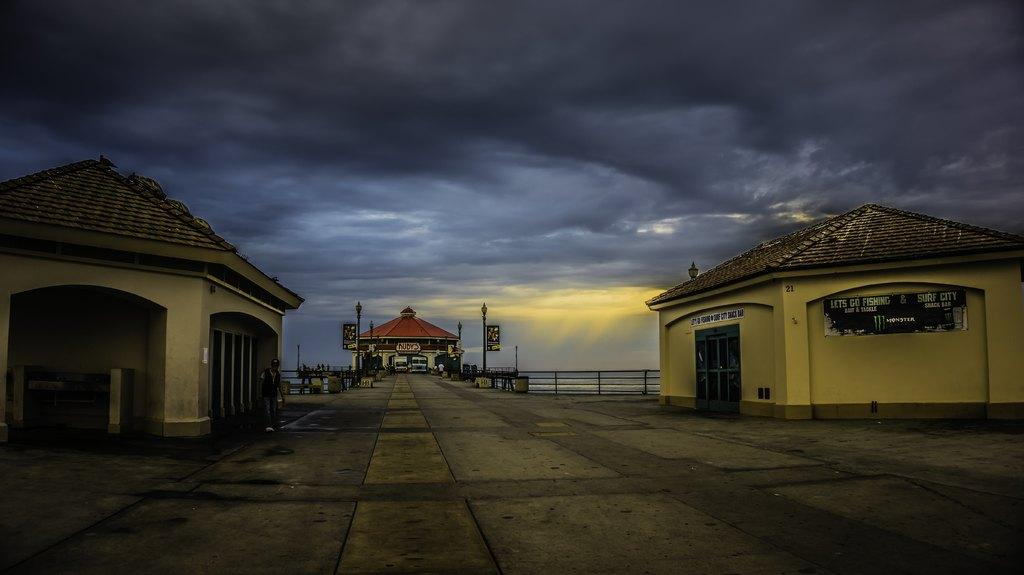What type of structures can be seen in the image? There are houses in the image. Can you describe the person in the image? There is a person in the image. What else is visible in the image besides houses and the person? There are vehicles and other objects in the image. What is visible at the top of the image? The sky is visible at the top of the image. What is visible at the bottom of the image? The road is visible at the bottom of the image. Where is the quartz located in the image? There is no quartz present in the image. What type of cow can be seen grazing on the road in the image? There is no cow present in the image; the road is visible but no animals are mentioned in the facts. 